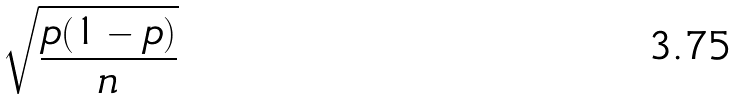Convert formula to latex. <formula><loc_0><loc_0><loc_500><loc_500>\sqrt { \frac { p ( 1 - p ) } { n } }</formula> 